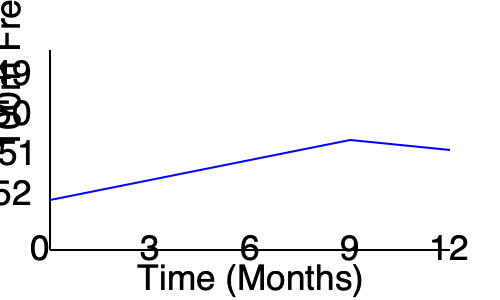Analyzing the graph of a swimmer's 100m freestyle performance over a year, what is the approximate improvement in seconds from the start to the best performance, and at which month did the swimmer achieve their fastest time? To answer this question, we need to follow these steps:

1. Identify the starting point: At month 0, the swimmer's time is approximately 52 seconds.

2. Find the lowest point on the graph: The graph reaches its lowest point at month 9, which represents the fastest time.

3. Estimate the time at the lowest point: At month 9, the time is approximately 50 seconds.

4. Calculate the improvement:
   Improvement = Starting time - Best time
   $52 - 50 = 2$ seconds

5. Identify the month of best performance: The lowest point on the graph occurs at month 9.

6. Note the slight increase in time after month 9, which is common in swimming as athletes can't continually improve and may have periods of slightly slower times.
Answer: 2 seconds improvement; fastest at month 9 